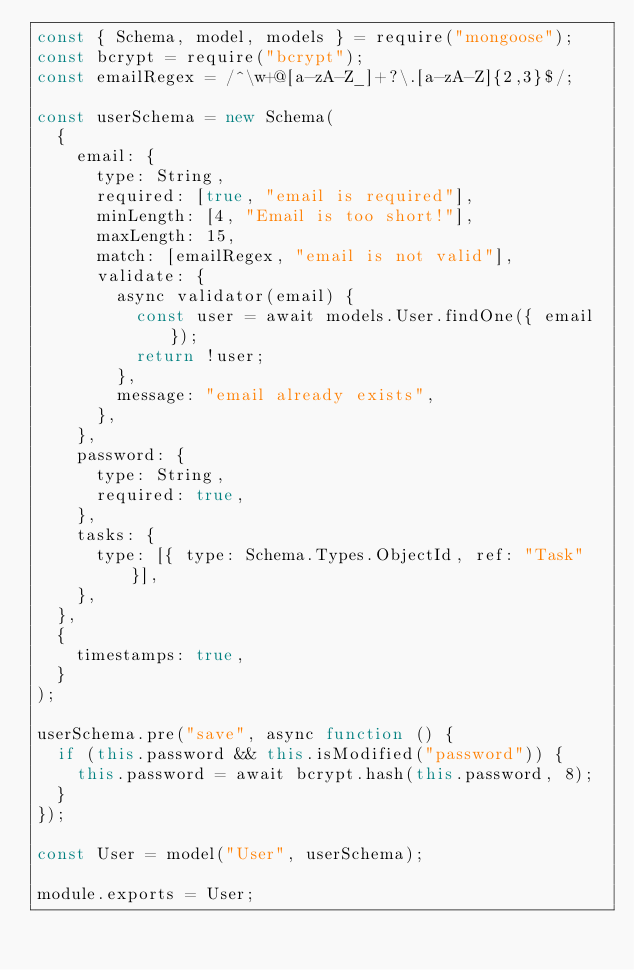<code> <loc_0><loc_0><loc_500><loc_500><_JavaScript_>const { Schema, model, models } = require("mongoose");
const bcrypt = require("bcrypt");
const emailRegex = /^\w+@[a-zA-Z_]+?\.[a-zA-Z]{2,3}$/;

const userSchema = new Schema(
  {
    email: {
      type: String,
      required: [true, "email is required"],
      minLength: [4, "Email is too short!"],
      maxLength: 15,
      match: [emailRegex, "email is not valid"],
      validate: {
        async validator(email) {
          const user = await models.User.findOne({ email });
          return !user;
        },
        message: "email already exists",
      },
    },
    password: {
      type: String,
      required: true,
    },
    tasks: {
      type: [{ type: Schema.Types.ObjectId, ref: "Task" }],
    },
  },
  {
    timestamps: true,
  }
);

userSchema.pre("save", async function () {
  if (this.password && this.isModified("password")) {
    this.password = await bcrypt.hash(this.password, 8);
  }
});

const User = model("User", userSchema);

module.exports = User;
</code> 